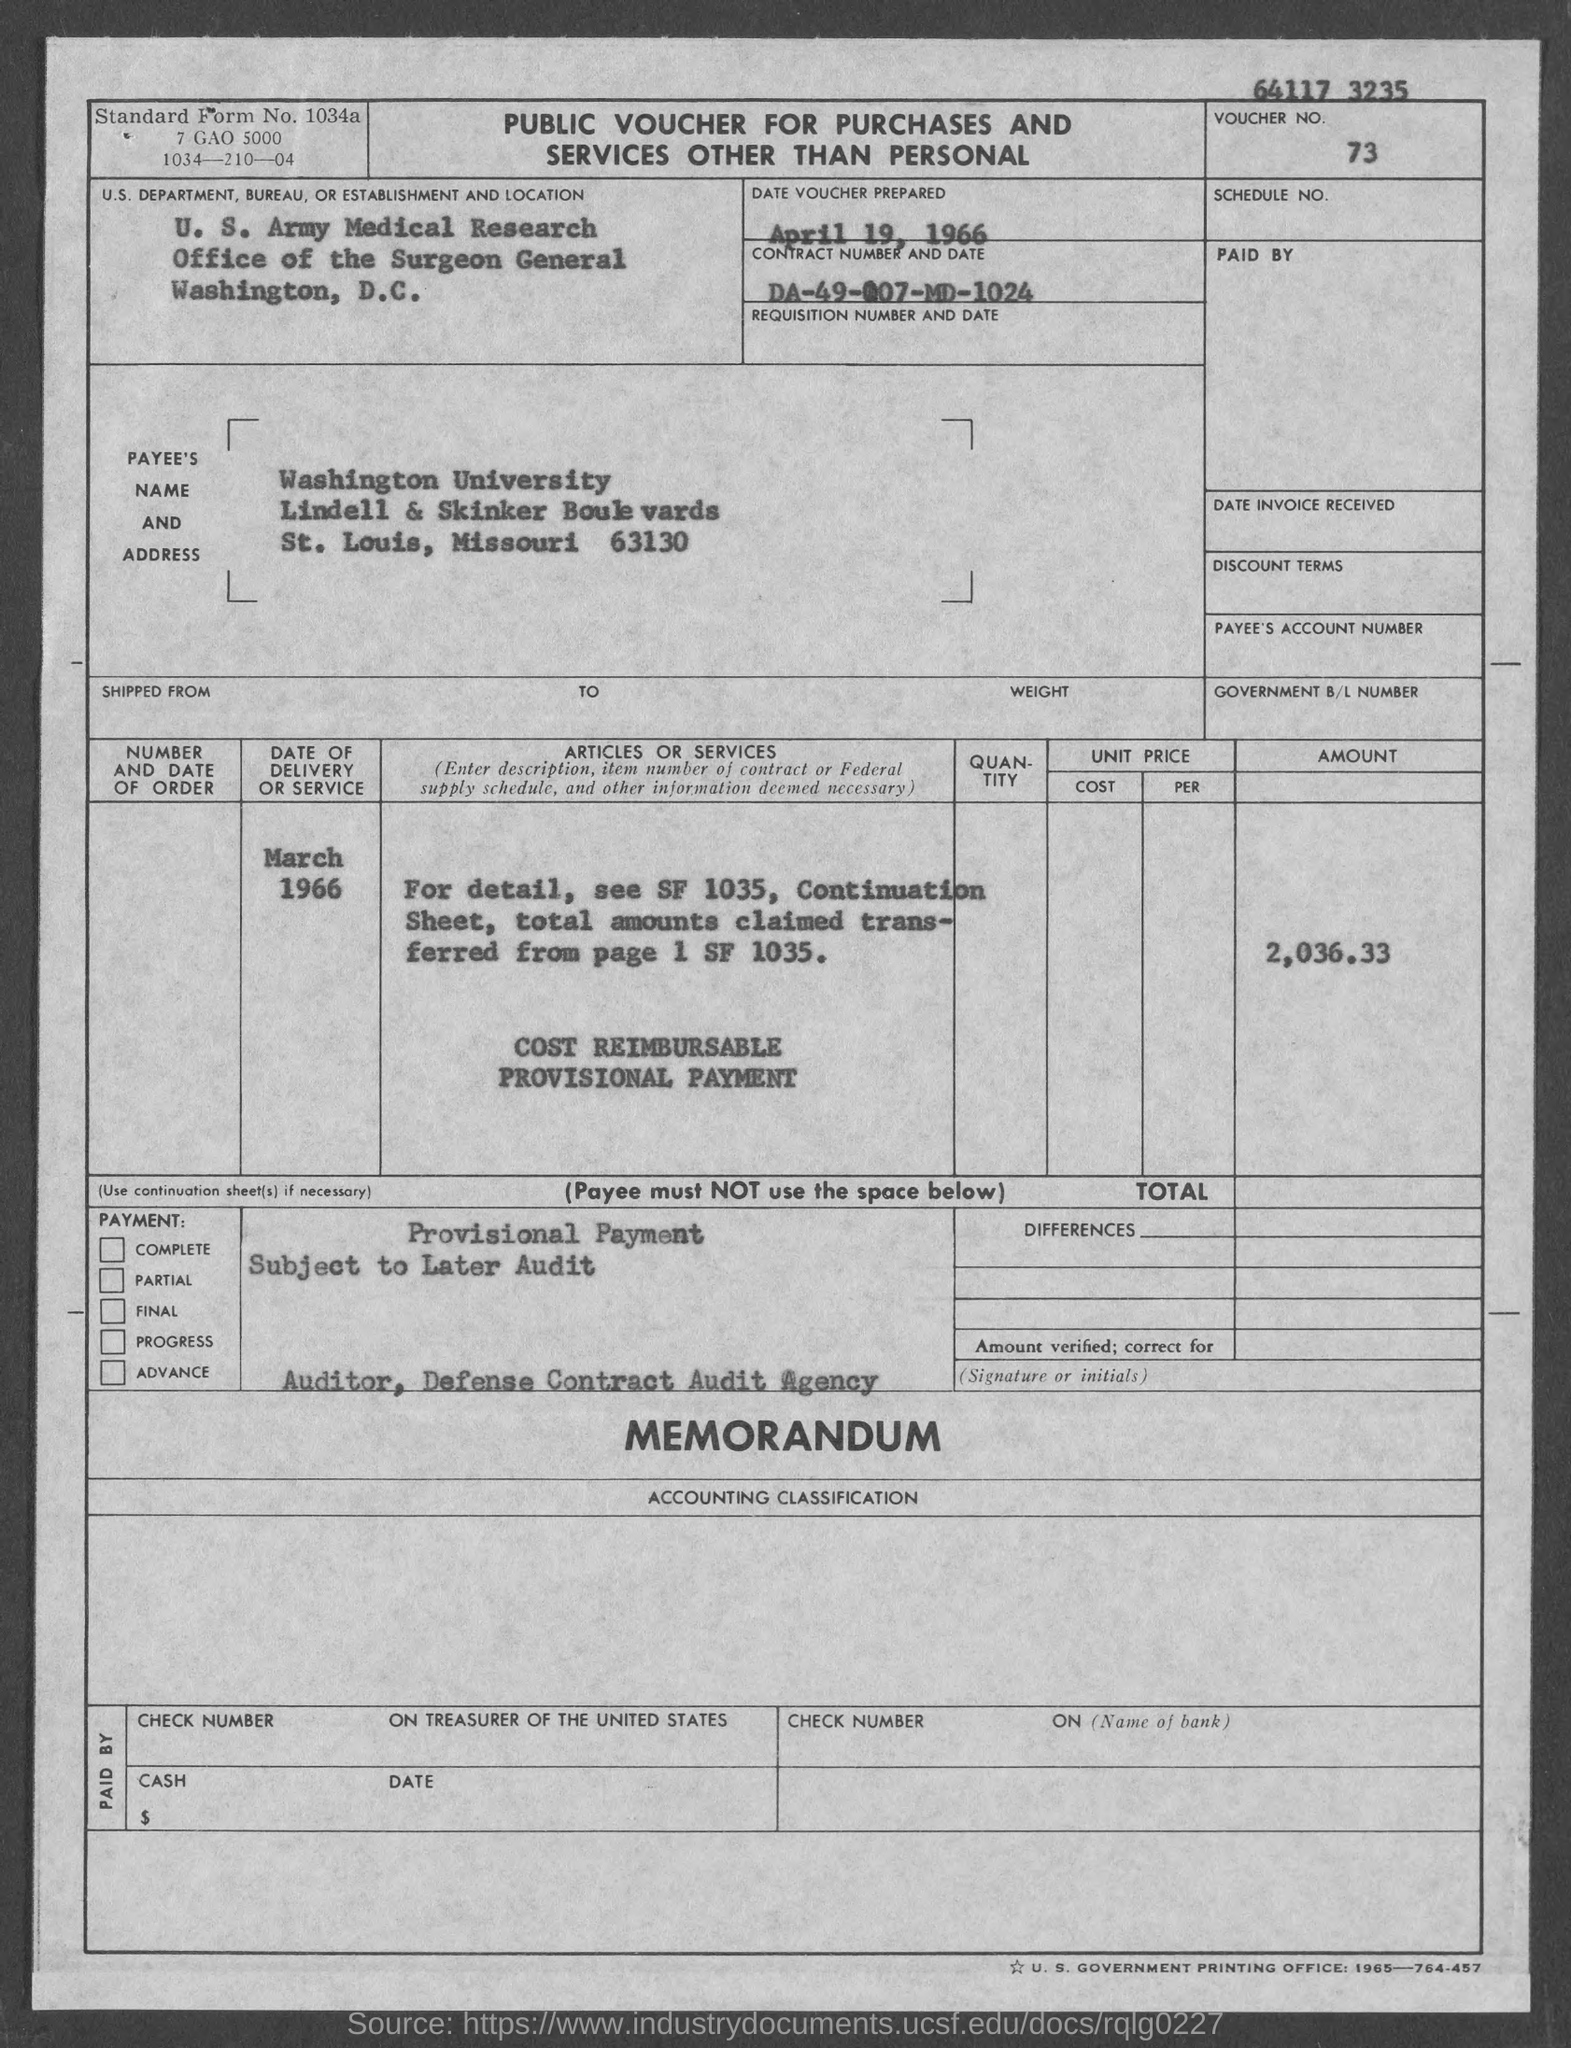Outline some significant characteristics in this image. The date of delivery or service was March 1966. What is the voucher number?" the man asked, pausing before continuing, "Seven-three-dash-dash. The contract number is DA-49-007-MD-1024. 